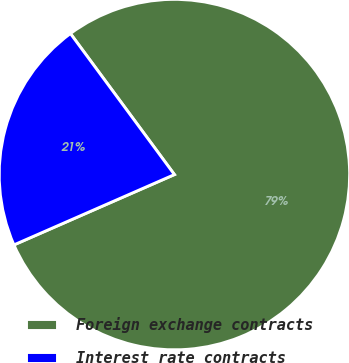<chart> <loc_0><loc_0><loc_500><loc_500><pie_chart><fcel>Foreign exchange contracts<fcel>Interest rate contracts<nl><fcel>78.54%<fcel>21.46%<nl></chart> 